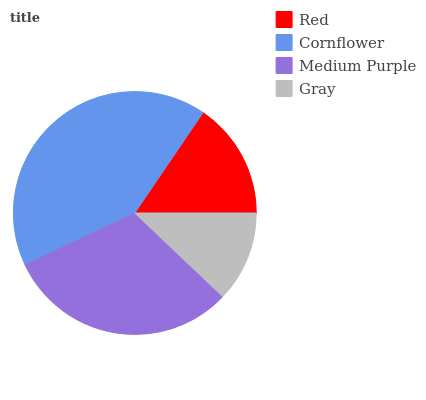Is Gray the minimum?
Answer yes or no. Yes. Is Cornflower the maximum?
Answer yes or no. Yes. Is Medium Purple the minimum?
Answer yes or no. No. Is Medium Purple the maximum?
Answer yes or no. No. Is Cornflower greater than Medium Purple?
Answer yes or no. Yes. Is Medium Purple less than Cornflower?
Answer yes or no. Yes. Is Medium Purple greater than Cornflower?
Answer yes or no. No. Is Cornflower less than Medium Purple?
Answer yes or no. No. Is Medium Purple the high median?
Answer yes or no. Yes. Is Red the low median?
Answer yes or no. Yes. Is Gray the high median?
Answer yes or no. No. Is Medium Purple the low median?
Answer yes or no. No. 